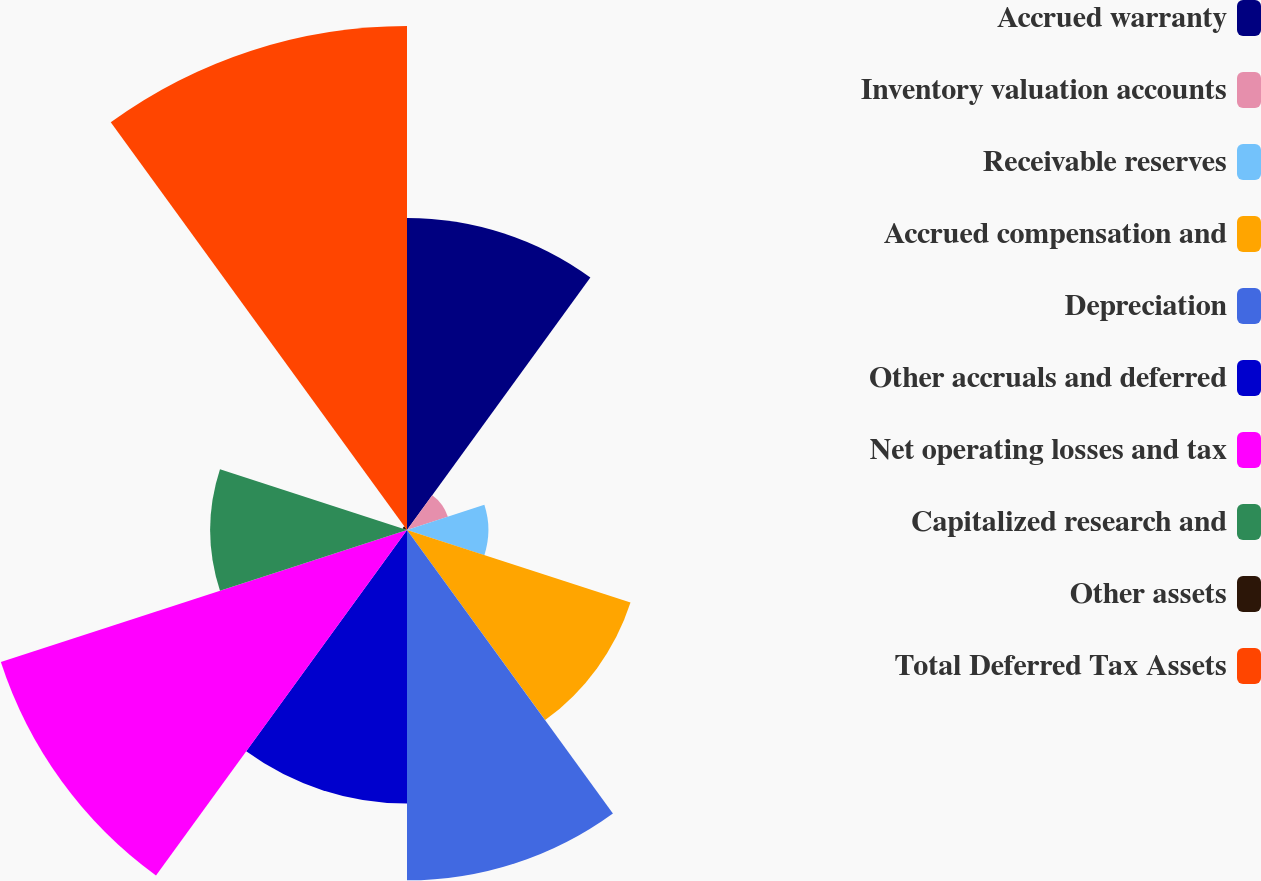Convert chart to OTSL. <chart><loc_0><loc_0><loc_500><loc_500><pie_chart><fcel>Accrued warranty<fcel>Inventory valuation accounts<fcel>Receivable reserves<fcel>Accrued compensation and<fcel>Depreciation<fcel>Other accruals and deferred<fcel>Net operating losses and tax<fcel>Capitalized research and<fcel>Other assets<fcel>Total Deferred Tax Assets<nl><fcel>12.85%<fcel>1.77%<fcel>3.35%<fcel>9.68%<fcel>14.43%<fcel>11.27%<fcel>17.59%<fcel>8.1%<fcel>0.19%<fcel>20.76%<nl></chart> 